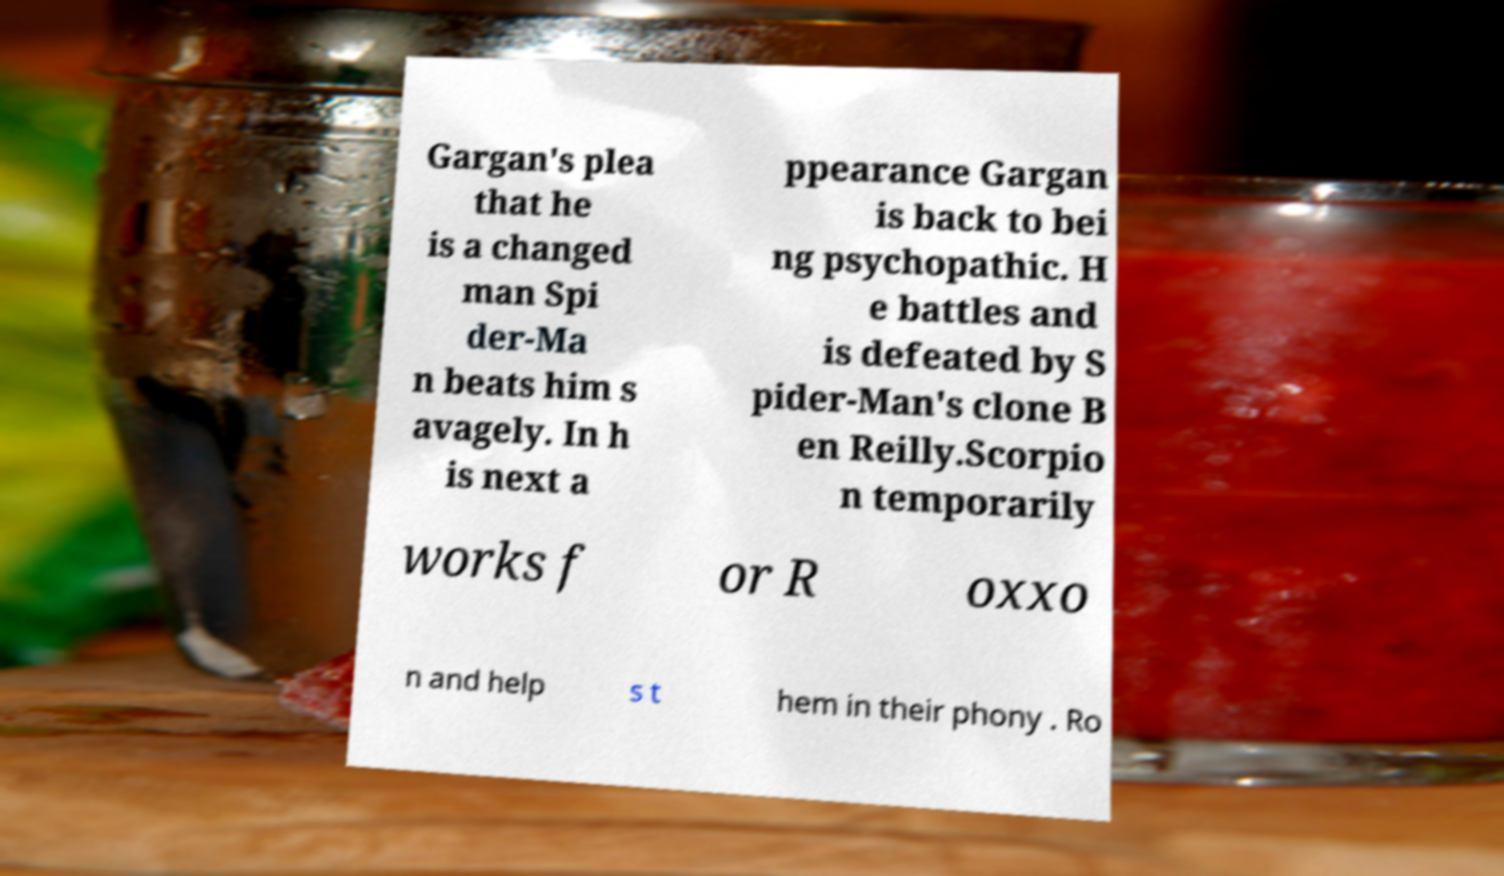Could you extract and type out the text from this image? Gargan's plea that he is a changed man Spi der-Ma n beats him s avagely. In h is next a ppearance Gargan is back to bei ng psychopathic. H e battles and is defeated by S pider-Man's clone B en Reilly.Scorpio n temporarily works f or R oxxo n and help s t hem in their phony . Ro 